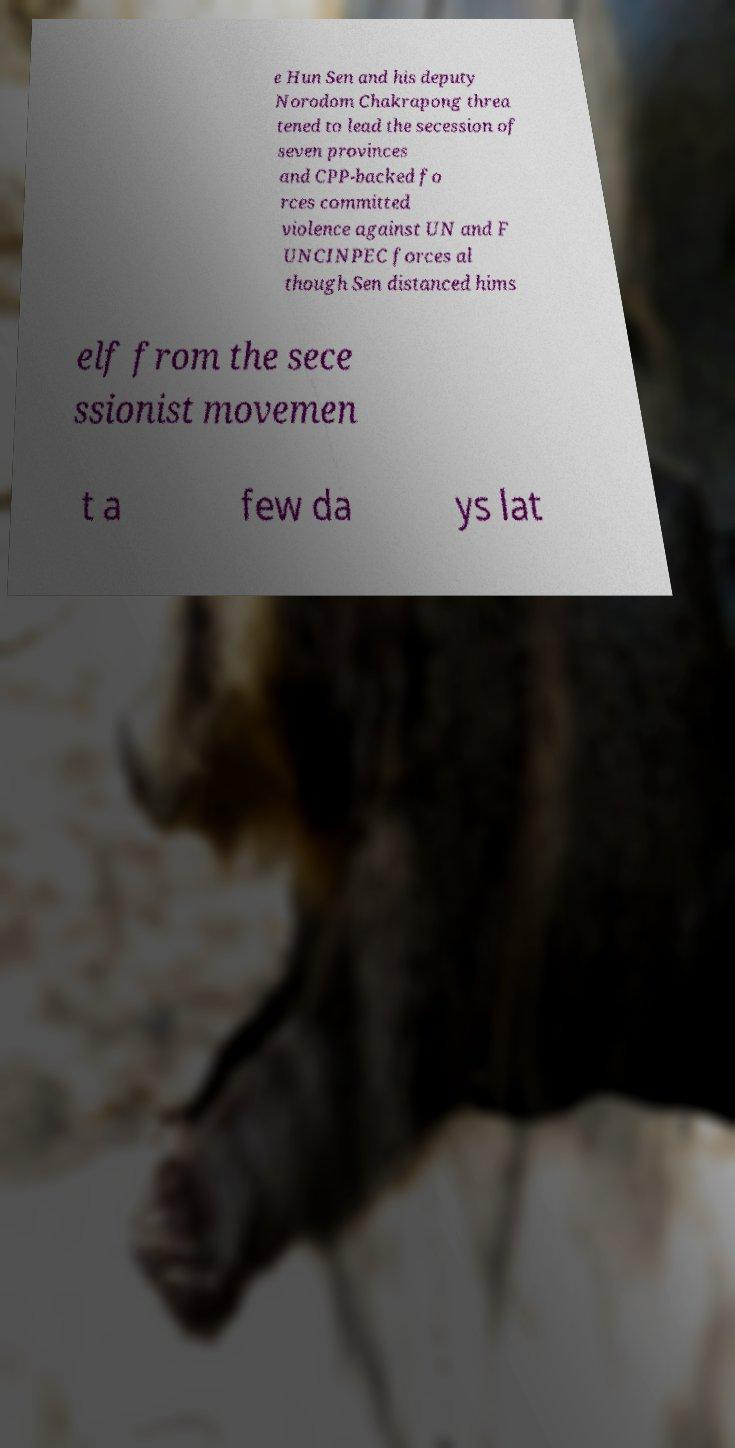For documentation purposes, I need the text within this image transcribed. Could you provide that? e Hun Sen and his deputy Norodom Chakrapong threa tened to lead the secession of seven provinces and CPP-backed fo rces committed violence against UN and F UNCINPEC forces al though Sen distanced hims elf from the sece ssionist movemen t a few da ys lat 